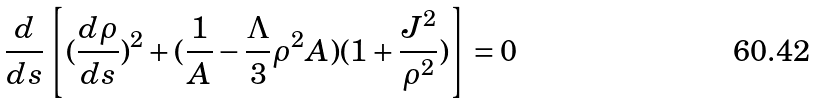<formula> <loc_0><loc_0><loc_500><loc_500>\frac { d } { d s } \left [ ( \frac { d \rho } { d s } ) ^ { 2 } + ( \frac { 1 } { A } - \frac { \Lambda } { 3 } \rho ^ { 2 } A ) ( 1 + \frac { J ^ { 2 } } { \rho ^ { 2 } } ) \right ] = 0 \,</formula> 